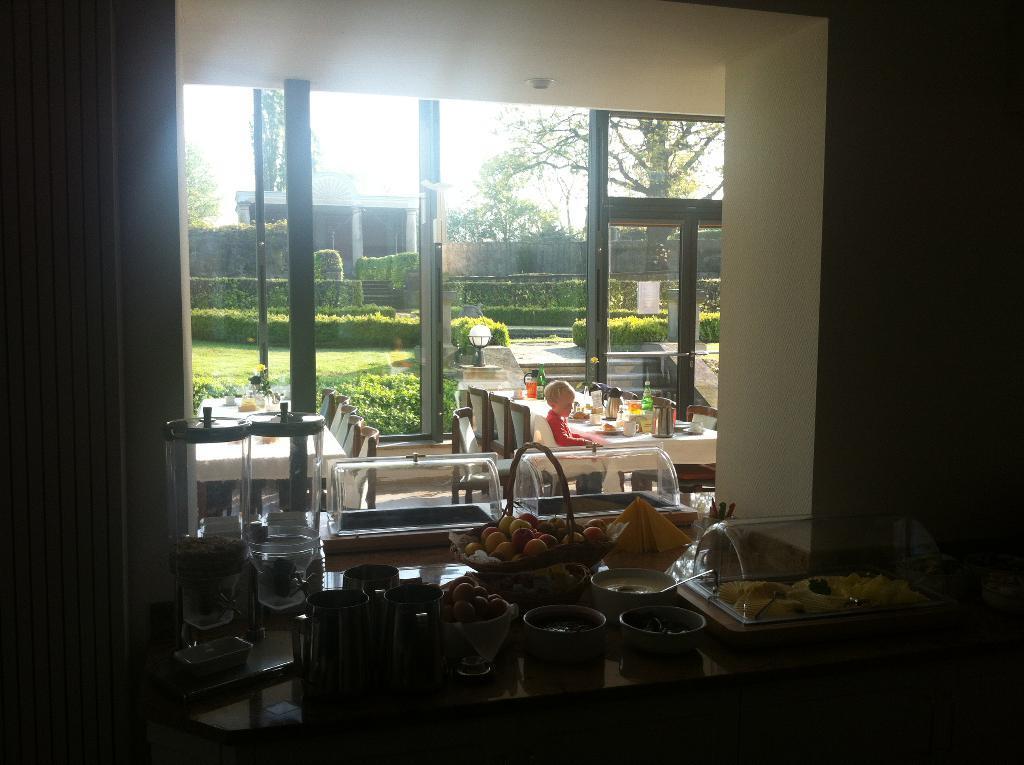Can you describe this image briefly? In this image we can see the fruits basket and also food items in the bowls. We can also see some objects and glasses on the wooden table. In the background we can see a boy sitting on the chair in front of the dining table and on the table we can see the plates, jars and some other objects. We can also see the empty chairs and also the glass window and through the glass window we can see the shrubs, path, grass, house and also tree and fence. We can also see the sky. 